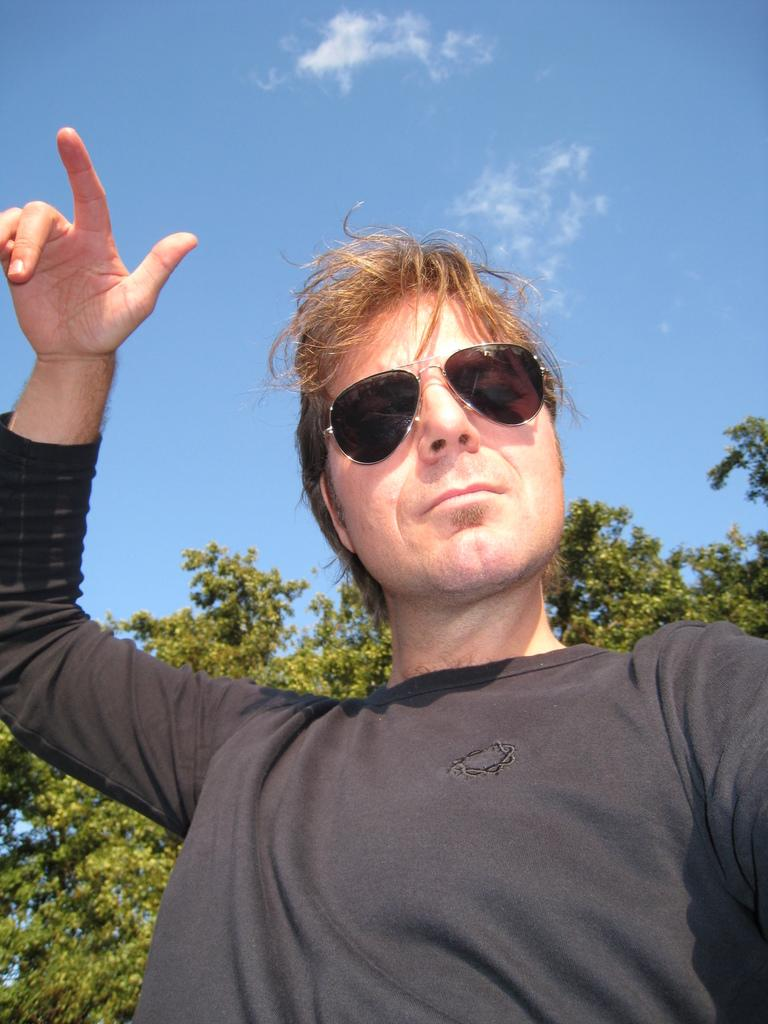What is the main subject of the image? There is a person in the image. What can be seen in the background of the image? There are trees and the sky visible in the background of the image. Can you tell me how many sponges are being smashed by the person in the image? There are no sponges or smashing actions present in the image; it features a person with a background of trees and the sky. 